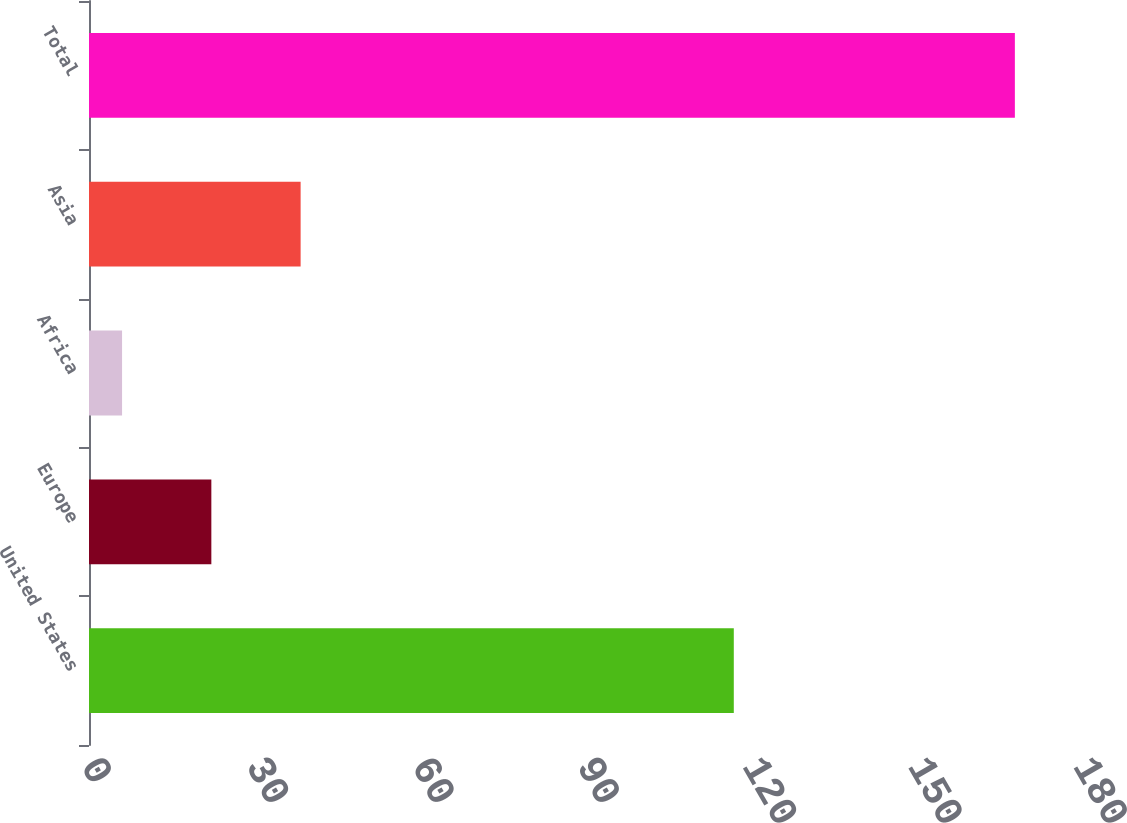<chart> <loc_0><loc_0><loc_500><loc_500><bar_chart><fcel>United States<fcel>Europe<fcel>Africa<fcel>Asia<fcel>Total<nl><fcel>117<fcel>22.2<fcel>6<fcel>38.4<fcel>168<nl></chart> 